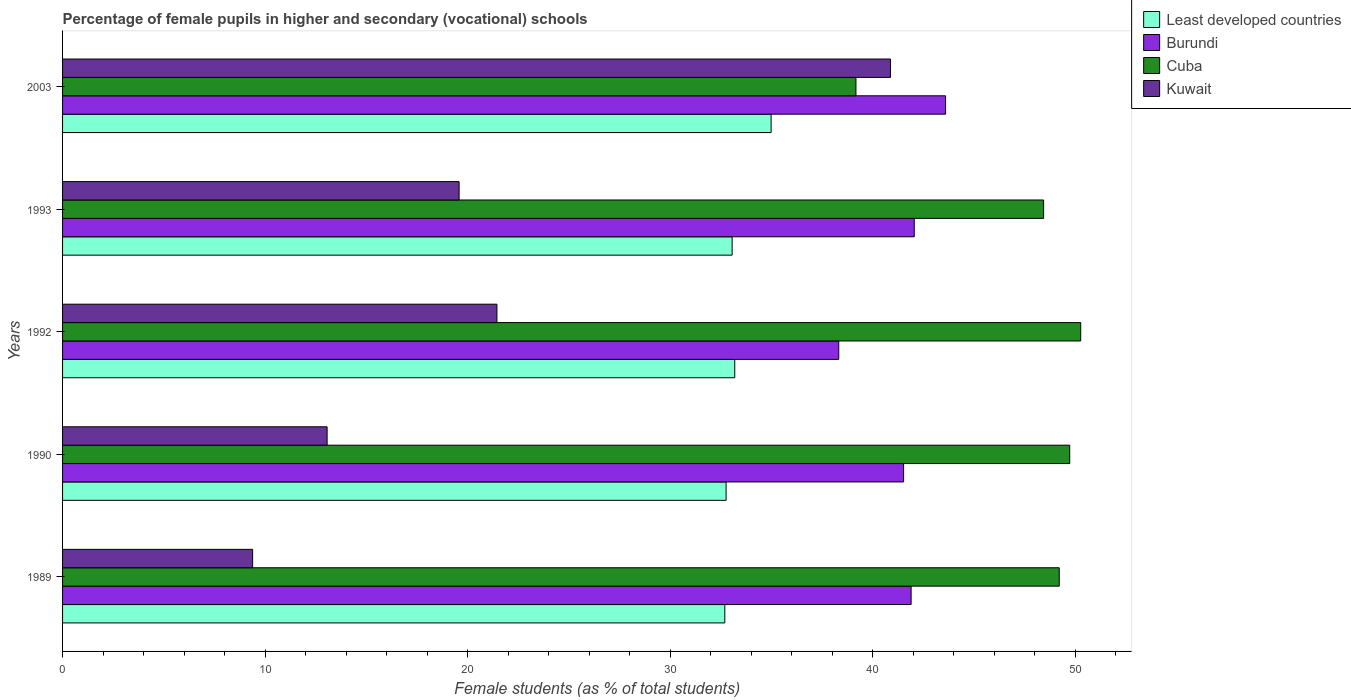How many different coloured bars are there?
Offer a terse response. 4. Are the number of bars on each tick of the Y-axis equal?
Ensure brevity in your answer.  Yes. What is the label of the 3rd group of bars from the top?
Your response must be concise. 1992. In how many cases, is the number of bars for a given year not equal to the number of legend labels?
Give a very brief answer. 0. What is the percentage of female pupils in higher and secondary schools in Least developed countries in 2003?
Your answer should be compact. 34.99. Across all years, what is the maximum percentage of female pupils in higher and secondary schools in Cuba?
Offer a terse response. 50.28. Across all years, what is the minimum percentage of female pupils in higher and secondary schools in Cuba?
Ensure brevity in your answer.  39.18. In which year was the percentage of female pupils in higher and secondary schools in Burundi maximum?
Your answer should be compact. 2003. In which year was the percentage of female pupils in higher and secondary schools in Kuwait minimum?
Ensure brevity in your answer.  1989. What is the total percentage of female pupils in higher and secondary schools in Burundi in the graph?
Provide a short and direct response. 207.43. What is the difference between the percentage of female pupils in higher and secondary schools in Kuwait in 1989 and that in 1990?
Offer a terse response. -3.68. What is the difference between the percentage of female pupils in higher and secondary schools in Burundi in 1990 and the percentage of female pupils in higher and secondary schools in Kuwait in 1989?
Provide a short and direct response. 32.15. What is the average percentage of female pupils in higher and secondary schools in Cuba per year?
Your answer should be compact. 47.37. In the year 1992, what is the difference between the percentage of female pupils in higher and secondary schools in Burundi and percentage of female pupils in higher and secondary schools in Cuba?
Your answer should be compact. -11.95. In how many years, is the percentage of female pupils in higher and secondary schools in Least developed countries greater than 40 %?
Offer a very short reply. 0. What is the ratio of the percentage of female pupils in higher and secondary schools in Kuwait in 1989 to that in 2003?
Your answer should be very brief. 0.23. Is the percentage of female pupils in higher and secondary schools in Least developed countries in 1990 less than that in 1993?
Keep it short and to the point. Yes. What is the difference between the highest and the second highest percentage of female pupils in higher and secondary schools in Burundi?
Give a very brief answer. 1.55. What is the difference between the highest and the lowest percentage of female pupils in higher and secondary schools in Cuba?
Offer a very short reply. 11.1. In how many years, is the percentage of female pupils in higher and secondary schools in Cuba greater than the average percentage of female pupils in higher and secondary schools in Cuba taken over all years?
Offer a very short reply. 4. What does the 1st bar from the top in 1993 represents?
Offer a very short reply. Kuwait. What does the 3rd bar from the bottom in 1989 represents?
Offer a terse response. Cuba. Is it the case that in every year, the sum of the percentage of female pupils in higher and secondary schools in Cuba and percentage of female pupils in higher and secondary schools in Burundi is greater than the percentage of female pupils in higher and secondary schools in Least developed countries?
Offer a terse response. Yes. How many bars are there?
Offer a very short reply. 20. How many years are there in the graph?
Ensure brevity in your answer.  5. Are the values on the major ticks of X-axis written in scientific E-notation?
Ensure brevity in your answer.  No. Does the graph contain grids?
Your answer should be very brief. No. What is the title of the graph?
Your response must be concise. Percentage of female pupils in higher and secondary (vocational) schools. What is the label or title of the X-axis?
Provide a short and direct response. Female students (as % of total students). What is the label or title of the Y-axis?
Provide a succinct answer. Years. What is the Female students (as % of total students) of Least developed countries in 1989?
Offer a very short reply. 32.7. What is the Female students (as % of total students) in Burundi in 1989?
Keep it short and to the point. 41.9. What is the Female students (as % of total students) of Cuba in 1989?
Give a very brief answer. 49.22. What is the Female students (as % of total students) in Kuwait in 1989?
Give a very brief answer. 9.39. What is the Female students (as % of total students) of Least developed countries in 1990?
Your response must be concise. 32.77. What is the Female students (as % of total students) of Burundi in 1990?
Keep it short and to the point. 41.53. What is the Female students (as % of total students) of Cuba in 1990?
Your response must be concise. 49.74. What is the Female students (as % of total students) in Kuwait in 1990?
Offer a terse response. 13.06. What is the Female students (as % of total students) in Least developed countries in 1992?
Your answer should be very brief. 33.2. What is the Female students (as % of total students) in Burundi in 1992?
Give a very brief answer. 38.33. What is the Female students (as % of total students) of Cuba in 1992?
Offer a terse response. 50.28. What is the Female students (as % of total students) in Kuwait in 1992?
Your response must be concise. 21.45. What is the Female students (as % of total students) in Least developed countries in 1993?
Ensure brevity in your answer.  33.07. What is the Female students (as % of total students) in Burundi in 1993?
Make the answer very short. 42.06. What is the Female students (as % of total students) of Cuba in 1993?
Keep it short and to the point. 48.45. What is the Female students (as % of total students) of Kuwait in 1993?
Give a very brief answer. 19.58. What is the Female students (as % of total students) of Least developed countries in 2003?
Keep it short and to the point. 34.99. What is the Female students (as % of total students) in Burundi in 2003?
Offer a terse response. 43.61. What is the Female students (as % of total students) in Cuba in 2003?
Keep it short and to the point. 39.18. What is the Female students (as % of total students) of Kuwait in 2003?
Provide a succinct answer. 40.88. Across all years, what is the maximum Female students (as % of total students) in Least developed countries?
Your response must be concise. 34.99. Across all years, what is the maximum Female students (as % of total students) of Burundi?
Make the answer very short. 43.61. Across all years, what is the maximum Female students (as % of total students) of Cuba?
Make the answer very short. 50.28. Across all years, what is the maximum Female students (as % of total students) in Kuwait?
Your answer should be compact. 40.88. Across all years, what is the minimum Female students (as % of total students) of Least developed countries?
Make the answer very short. 32.7. Across all years, what is the minimum Female students (as % of total students) in Burundi?
Give a very brief answer. 38.33. Across all years, what is the minimum Female students (as % of total students) of Cuba?
Offer a very short reply. 39.18. Across all years, what is the minimum Female students (as % of total students) of Kuwait?
Provide a succinct answer. 9.39. What is the total Female students (as % of total students) in Least developed countries in the graph?
Your answer should be very brief. 166.72. What is the total Female students (as % of total students) in Burundi in the graph?
Your answer should be compact. 207.43. What is the total Female students (as % of total students) in Cuba in the graph?
Make the answer very short. 236.87. What is the total Female students (as % of total students) in Kuwait in the graph?
Give a very brief answer. 104.37. What is the difference between the Female students (as % of total students) of Least developed countries in 1989 and that in 1990?
Keep it short and to the point. -0.06. What is the difference between the Female students (as % of total students) in Burundi in 1989 and that in 1990?
Make the answer very short. 0.37. What is the difference between the Female students (as % of total students) in Cuba in 1989 and that in 1990?
Give a very brief answer. -0.52. What is the difference between the Female students (as % of total students) of Kuwait in 1989 and that in 1990?
Your answer should be very brief. -3.68. What is the difference between the Female students (as % of total students) of Least developed countries in 1989 and that in 1992?
Provide a succinct answer. -0.49. What is the difference between the Female students (as % of total students) of Burundi in 1989 and that in 1992?
Your answer should be compact. 3.57. What is the difference between the Female students (as % of total students) of Cuba in 1989 and that in 1992?
Provide a short and direct response. -1.06. What is the difference between the Female students (as % of total students) in Kuwait in 1989 and that in 1992?
Your answer should be very brief. -12.07. What is the difference between the Female students (as % of total students) in Least developed countries in 1989 and that in 1993?
Your answer should be very brief. -0.36. What is the difference between the Female students (as % of total students) of Burundi in 1989 and that in 1993?
Offer a very short reply. -0.15. What is the difference between the Female students (as % of total students) of Cuba in 1989 and that in 1993?
Your answer should be compact. 0.77. What is the difference between the Female students (as % of total students) in Kuwait in 1989 and that in 1993?
Give a very brief answer. -10.2. What is the difference between the Female students (as % of total students) of Least developed countries in 1989 and that in 2003?
Your answer should be compact. -2.29. What is the difference between the Female students (as % of total students) in Burundi in 1989 and that in 2003?
Give a very brief answer. -1.7. What is the difference between the Female students (as % of total students) of Cuba in 1989 and that in 2003?
Your answer should be compact. 10.04. What is the difference between the Female students (as % of total students) of Kuwait in 1989 and that in 2003?
Your response must be concise. -31.5. What is the difference between the Female students (as % of total students) in Least developed countries in 1990 and that in 1992?
Keep it short and to the point. -0.43. What is the difference between the Female students (as % of total students) in Burundi in 1990 and that in 1992?
Give a very brief answer. 3.2. What is the difference between the Female students (as % of total students) of Cuba in 1990 and that in 1992?
Make the answer very short. -0.54. What is the difference between the Female students (as % of total students) of Kuwait in 1990 and that in 1992?
Your answer should be compact. -8.39. What is the difference between the Female students (as % of total students) in Least developed countries in 1990 and that in 1993?
Give a very brief answer. -0.3. What is the difference between the Female students (as % of total students) of Burundi in 1990 and that in 1993?
Provide a succinct answer. -0.53. What is the difference between the Female students (as % of total students) in Cuba in 1990 and that in 1993?
Your answer should be very brief. 1.29. What is the difference between the Female students (as % of total students) in Kuwait in 1990 and that in 1993?
Your answer should be very brief. -6.52. What is the difference between the Female students (as % of total students) of Least developed countries in 1990 and that in 2003?
Offer a terse response. -2.22. What is the difference between the Female students (as % of total students) of Burundi in 1990 and that in 2003?
Offer a terse response. -2.07. What is the difference between the Female students (as % of total students) of Cuba in 1990 and that in 2003?
Offer a terse response. 10.56. What is the difference between the Female students (as % of total students) of Kuwait in 1990 and that in 2003?
Your answer should be very brief. -27.82. What is the difference between the Female students (as % of total students) of Least developed countries in 1992 and that in 1993?
Provide a succinct answer. 0.13. What is the difference between the Female students (as % of total students) in Burundi in 1992 and that in 1993?
Your response must be concise. -3.73. What is the difference between the Female students (as % of total students) of Cuba in 1992 and that in 1993?
Your answer should be compact. 1.83. What is the difference between the Female students (as % of total students) of Kuwait in 1992 and that in 1993?
Give a very brief answer. 1.87. What is the difference between the Female students (as % of total students) of Least developed countries in 1992 and that in 2003?
Provide a short and direct response. -1.8. What is the difference between the Female students (as % of total students) of Burundi in 1992 and that in 2003?
Ensure brevity in your answer.  -5.28. What is the difference between the Female students (as % of total students) of Cuba in 1992 and that in 2003?
Keep it short and to the point. 11.1. What is the difference between the Female students (as % of total students) in Kuwait in 1992 and that in 2003?
Offer a very short reply. -19.43. What is the difference between the Female students (as % of total students) of Least developed countries in 1993 and that in 2003?
Offer a very short reply. -1.92. What is the difference between the Female students (as % of total students) of Burundi in 1993 and that in 2003?
Ensure brevity in your answer.  -1.55. What is the difference between the Female students (as % of total students) in Cuba in 1993 and that in 2003?
Your answer should be very brief. 9.27. What is the difference between the Female students (as % of total students) in Kuwait in 1993 and that in 2003?
Your response must be concise. -21.3. What is the difference between the Female students (as % of total students) in Least developed countries in 1989 and the Female students (as % of total students) in Burundi in 1990?
Your response must be concise. -8.83. What is the difference between the Female students (as % of total students) of Least developed countries in 1989 and the Female students (as % of total students) of Cuba in 1990?
Your answer should be compact. -17.03. What is the difference between the Female students (as % of total students) in Least developed countries in 1989 and the Female students (as % of total students) in Kuwait in 1990?
Ensure brevity in your answer.  19.64. What is the difference between the Female students (as % of total students) of Burundi in 1989 and the Female students (as % of total students) of Cuba in 1990?
Your answer should be very brief. -7.83. What is the difference between the Female students (as % of total students) of Burundi in 1989 and the Female students (as % of total students) of Kuwait in 1990?
Offer a very short reply. 28.84. What is the difference between the Female students (as % of total students) of Cuba in 1989 and the Female students (as % of total students) of Kuwait in 1990?
Make the answer very short. 36.16. What is the difference between the Female students (as % of total students) in Least developed countries in 1989 and the Female students (as % of total students) in Burundi in 1992?
Provide a succinct answer. -5.63. What is the difference between the Female students (as % of total students) in Least developed countries in 1989 and the Female students (as % of total students) in Cuba in 1992?
Make the answer very short. -17.58. What is the difference between the Female students (as % of total students) in Least developed countries in 1989 and the Female students (as % of total students) in Kuwait in 1992?
Offer a terse response. 11.25. What is the difference between the Female students (as % of total students) of Burundi in 1989 and the Female students (as % of total students) of Cuba in 1992?
Make the answer very short. -8.38. What is the difference between the Female students (as % of total students) of Burundi in 1989 and the Female students (as % of total students) of Kuwait in 1992?
Your response must be concise. 20.45. What is the difference between the Female students (as % of total students) in Cuba in 1989 and the Female students (as % of total students) in Kuwait in 1992?
Give a very brief answer. 27.77. What is the difference between the Female students (as % of total students) of Least developed countries in 1989 and the Female students (as % of total students) of Burundi in 1993?
Offer a very short reply. -9.36. What is the difference between the Female students (as % of total students) in Least developed countries in 1989 and the Female students (as % of total students) in Cuba in 1993?
Make the answer very short. -15.74. What is the difference between the Female students (as % of total students) in Least developed countries in 1989 and the Female students (as % of total students) in Kuwait in 1993?
Ensure brevity in your answer.  13.12. What is the difference between the Female students (as % of total students) in Burundi in 1989 and the Female students (as % of total students) in Cuba in 1993?
Your answer should be very brief. -6.54. What is the difference between the Female students (as % of total students) of Burundi in 1989 and the Female students (as % of total students) of Kuwait in 1993?
Make the answer very short. 22.32. What is the difference between the Female students (as % of total students) in Cuba in 1989 and the Female students (as % of total students) in Kuwait in 1993?
Offer a terse response. 29.64. What is the difference between the Female students (as % of total students) of Least developed countries in 1989 and the Female students (as % of total students) of Burundi in 2003?
Make the answer very short. -10.9. What is the difference between the Female students (as % of total students) of Least developed countries in 1989 and the Female students (as % of total students) of Cuba in 2003?
Offer a very short reply. -6.48. What is the difference between the Female students (as % of total students) of Least developed countries in 1989 and the Female students (as % of total students) of Kuwait in 2003?
Offer a very short reply. -8.18. What is the difference between the Female students (as % of total students) of Burundi in 1989 and the Female students (as % of total students) of Cuba in 2003?
Give a very brief answer. 2.72. What is the difference between the Female students (as % of total students) of Burundi in 1989 and the Female students (as % of total students) of Kuwait in 2003?
Give a very brief answer. 1.02. What is the difference between the Female students (as % of total students) in Cuba in 1989 and the Female students (as % of total students) in Kuwait in 2003?
Offer a terse response. 8.34. What is the difference between the Female students (as % of total students) of Least developed countries in 1990 and the Female students (as % of total students) of Burundi in 1992?
Ensure brevity in your answer.  -5.56. What is the difference between the Female students (as % of total students) of Least developed countries in 1990 and the Female students (as % of total students) of Cuba in 1992?
Keep it short and to the point. -17.51. What is the difference between the Female students (as % of total students) of Least developed countries in 1990 and the Female students (as % of total students) of Kuwait in 1992?
Your answer should be compact. 11.32. What is the difference between the Female students (as % of total students) of Burundi in 1990 and the Female students (as % of total students) of Cuba in 1992?
Ensure brevity in your answer.  -8.75. What is the difference between the Female students (as % of total students) of Burundi in 1990 and the Female students (as % of total students) of Kuwait in 1992?
Your answer should be very brief. 20.08. What is the difference between the Female students (as % of total students) of Cuba in 1990 and the Female students (as % of total students) of Kuwait in 1992?
Provide a short and direct response. 28.29. What is the difference between the Female students (as % of total students) in Least developed countries in 1990 and the Female students (as % of total students) in Burundi in 1993?
Give a very brief answer. -9.29. What is the difference between the Female students (as % of total students) of Least developed countries in 1990 and the Female students (as % of total students) of Cuba in 1993?
Your answer should be compact. -15.68. What is the difference between the Female students (as % of total students) in Least developed countries in 1990 and the Female students (as % of total students) in Kuwait in 1993?
Your answer should be very brief. 13.18. What is the difference between the Female students (as % of total students) of Burundi in 1990 and the Female students (as % of total students) of Cuba in 1993?
Make the answer very short. -6.91. What is the difference between the Female students (as % of total students) in Burundi in 1990 and the Female students (as % of total students) in Kuwait in 1993?
Provide a short and direct response. 21.95. What is the difference between the Female students (as % of total students) in Cuba in 1990 and the Female students (as % of total students) in Kuwait in 1993?
Give a very brief answer. 30.15. What is the difference between the Female students (as % of total students) of Least developed countries in 1990 and the Female students (as % of total students) of Burundi in 2003?
Provide a short and direct response. -10.84. What is the difference between the Female students (as % of total students) in Least developed countries in 1990 and the Female students (as % of total students) in Cuba in 2003?
Provide a succinct answer. -6.41. What is the difference between the Female students (as % of total students) of Least developed countries in 1990 and the Female students (as % of total students) of Kuwait in 2003?
Provide a succinct answer. -8.12. What is the difference between the Female students (as % of total students) in Burundi in 1990 and the Female students (as % of total students) in Cuba in 2003?
Offer a very short reply. 2.35. What is the difference between the Female students (as % of total students) in Burundi in 1990 and the Female students (as % of total students) in Kuwait in 2003?
Provide a succinct answer. 0.65. What is the difference between the Female students (as % of total students) in Cuba in 1990 and the Female students (as % of total students) in Kuwait in 2003?
Keep it short and to the point. 8.85. What is the difference between the Female students (as % of total students) in Least developed countries in 1992 and the Female students (as % of total students) in Burundi in 1993?
Your answer should be compact. -8.86. What is the difference between the Female students (as % of total students) of Least developed countries in 1992 and the Female students (as % of total students) of Cuba in 1993?
Your answer should be very brief. -15.25. What is the difference between the Female students (as % of total students) of Least developed countries in 1992 and the Female students (as % of total students) of Kuwait in 1993?
Keep it short and to the point. 13.61. What is the difference between the Female students (as % of total students) of Burundi in 1992 and the Female students (as % of total students) of Cuba in 1993?
Your response must be concise. -10.12. What is the difference between the Female students (as % of total students) in Burundi in 1992 and the Female students (as % of total students) in Kuwait in 1993?
Your answer should be very brief. 18.75. What is the difference between the Female students (as % of total students) in Cuba in 1992 and the Female students (as % of total students) in Kuwait in 1993?
Your answer should be compact. 30.7. What is the difference between the Female students (as % of total students) of Least developed countries in 1992 and the Female students (as % of total students) of Burundi in 2003?
Your response must be concise. -10.41. What is the difference between the Female students (as % of total students) in Least developed countries in 1992 and the Female students (as % of total students) in Cuba in 2003?
Offer a very short reply. -5.99. What is the difference between the Female students (as % of total students) in Least developed countries in 1992 and the Female students (as % of total students) in Kuwait in 2003?
Your response must be concise. -7.69. What is the difference between the Female students (as % of total students) in Burundi in 1992 and the Female students (as % of total students) in Cuba in 2003?
Keep it short and to the point. -0.85. What is the difference between the Female students (as % of total students) in Burundi in 1992 and the Female students (as % of total students) in Kuwait in 2003?
Give a very brief answer. -2.55. What is the difference between the Female students (as % of total students) of Cuba in 1992 and the Female students (as % of total students) of Kuwait in 2003?
Ensure brevity in your answer.  9.4. What is the difference between the Female students (as % of total students) of Least developed countries in 1993 and the Female students (as % of total students) of Burundi in 2003?
Your answer should be very brief. -10.54. What is the difference between the Female students (as % of total students) in Least developed countries in 1993 and the Female students (as % of total students) in Cuba in 2003?
Your answer should be very brief. -6.11. What is the difference between the Female students (as % of total students) in Least developed countries in 1993 and the Female students (as % of total students) in Kuwait in 2003?
Provide a succinct answer. -7.82. What is the difference between the Female students (as % of total students) in Burundi in 1993 and the Female students (as % of total students) in Cuba in 2003?
Your response must be concise. 2.88. What is the difference between the Female students (as % of total students) of Burundi in 1993 and the Female students (as % of total students) of Kuwait in 2003?
Keep it short and to the point. 1.18. What is the difference between the Female students (as % of total students) in Cuba in 1993 and the Female students (as % of total students) in Kuwait in 2003?
Provide a short and direct response. 7.56. What is the average Female students (as % of total students) of Least developed countries per year?
Offer a terse response. 33.34. What is the average Female students (as % of total students) in Burundi per year?
Ensure brevity in your answer.  41.49. What is the average Female students (as % of total students) in Cuba per year?
Your answer should be very brief. 47.37. What is the average Female students (as % of total students) in Kuwait per year?
Make the answer very short. 20.87. In the year 1989, what is the difference between the Female students (as % of total students) of Least developed countries and Female students (as % of total students) of Burundi?
Provide a succinct answer. -9.2. In the year 1989, what is the difference between the Female students (as % of total students) in Least developed countries and Female students (as % of total students) in Cuba?
Ensure brevity in your answer.  -16.52. In the year 1989, what is the difference between the Female students (as % of total students) in Least developed countries and Female students (as % of total students) in Kuwait?
Ensure brevity in your answer.  23.32. In the year 1989, what is the difference between the Female students (as % of total students) of Burundi and Female students (as % of total students) of Cuba?
Make the answer very short. -7.32. In the year 1989, what is the difference between the Female students (as % of total students) of Burundi and Female students (as % of total students) of Kuwait?
Your answer should be compact. 32.52. In the year 1989, what is the difference between the Female students (as % of total students) of Cuba and Female students (as % of total students) of Kuwait?
Make the answer very short. 39.83. In the year 1990, what is the difference between the Female students (as % of total students) in Least developed countries and Female students (as % of total students) in Burundi?
Provide a short and direct response. -8.77. In the year 1990, what is the difference between the Female students (as % of total students) of Least developed countries and Female students (as % of total students) of Cuba?
Your answer should be compact. -16.97. In the year 1990, what is the difference between the Female students (as % of total students) in Least developed countries and Female students (as % of total students) in Kuwait?
Your response must be concise. 19.7. In the year 1990, what is the difference between the Female students (as % of total students) of Burundi and Female students (as % of total students) of Cuba?
Offer a very short reply. -8.2. In the year 1990, what is the difference between the Female students (as % of total students) of Burundi and Female students (as % of total students) of Kuwait?
Offer a very short reply. 28.47. In the year 1990, what is the difference between the Female students (as % of total students) in Cuba and Female students (as % of total students) in Kuwait?
Your response must be concise. 36.67. In the year 1992, what is the difference between the Female students (as % of total students) in Least developed countries and Female students (as % of total students) in Burundi?
Your answer should be very brief. -5.14. In the year 1992, what is the difference between the Female students (as % of total students) of Least developed countries and Female students (as % of total students) of Cuba?
Keep it short and to the point. -17.09. In the year 1992, what is the difference between the Female students (as % of total students) of Least developed countries and Female students (as % of total students) of Kuwait?
Provide a short and direct response. 11.74. In the year 1992, what is the difference between the Female students (as % of total students) of Burundi and Female students (as % of total students) of Cuba?
Your answer should be very brief. -11.95. In the year 1992, what is the difference between the Female students (as % of total students) of Burundi and Female students (as % of total students) of Kuwait?
Make the answer very short. 16.88. In the year 1992, what is the difference between the Female students (as % of total students) of Cuba and Female students (as % of total students) of Kuwait?
Provide a short and direct response. 28.83. In the year 1993, what is the difference between the Female students (as % of total students) of Least developed countries and Female students (as % of total students) of Burundi?
Offer a very short reply. -8.99. In the year 1993, what is the difference between the Female students (as % of total students) of Least developed countries and Female students (as % of total students) of Cuba?
Give a very brief answer. -15.38. In the year 1993, what is the difference between the Female students (as % of total students) in Least developed countries and Female students (as % of total students) in Kuwait?
Offer a terse response. 13.48. In the year 1993, what is the difference between the Female students (as % of total students) of Burundi and Female students (as % of total students) of Cuba?
Keep it short and to the point. -6.39. In the year 1993, what is the difference between the Female students (as % of total students) of Burundi and Female students (as % of total students) of Kuwait?
Make the answer very short. 22.48. In the year 1993, what is the difference between the Female students (as % of total students) of Cuba and Female students (as % of total students) of Kuwait?
Your answer should be compact. 28.86. In the year 2003, what is the difference between the Female students (as % of total students) in Least developed countries and Female students (as % of total students) in Burundi?
Ensure brevity in your answer.  -8.62. In the year 2003, what is the difference between the Female students (as % of total students) in Least developed countries and Female students (as % of total students) in Cuba?
Your response must be concise. -4.19. In the year 2003, what is the difference between the Female students (as % of total students) in Least developed countries and Female students (as % of total students) in Kuwait?
Offer a terse response. -5.89. In the year 2003, what is the difference between the Female students (as % of total students) in Burundi and Female students (as % of total students) in Cuba?
Make the answer very short. 4.43. In the year 2003, what is the difference between the Female students (as % of total students) of Burundi and Female students (as % of total students) of Kuwait?
Ensure brevity in your answer.  2.72. In the year 2003, what is the difference between the Female students (as % of total students) of Cuba and Female students (as % of total students) of Kuwait?
Make the answer very short. -1.7. What is the ratio of the Female students (as % of total students) in Burundi in 1989 to that in 1990?
Give a very brief answer. 1.01. What is the ratio of the Female students (as % of total students) of Cuba in 1989 to that in 1990?
Provide a short and direct response. 0.99. What is the ratio of the Female students (as % of total students) of Kuwait in 1989 to that in 1990?
Your answer should be very brief. 0.72. What is the ratio of the Female students (as % of total students) of Least developed countries in 1989 to that in 1992?
Offer a terse response. 0.99. What is the ratio of the Female students (as % of total students) in Burundi in 1989 to that in 1992?
Make the answer very short. 1.09. What is the ratio of the Female students (as % of total students) in Cuba in 1989 to that in 1992?
Ensure brevity in your answer.  0.98. What is the ratio of the Female students (as % of total students) in Kuwait in 1989 to that in 1992?
Provide a short and direct response. 0.44. What is the ratio of the Female students (as % of total students) in Burundi in 1989 to that in 1993?
Make the answer very short. 1. What is the ratio of the Female students (as % of total students) in Cuba in 1989 to that in 1993?
Offer a very short reply. 1.02. What is the ratio of the Female students (as % of total students) of Kuwait in 1989 to that in 1993?
Ensure brevity in your answer.  0.48. What is the ratio of the Female students (as % of total students) in Least developed countries in 1989 to that in 2003?
Your response must be concise. 0.93. What is the ratio of the Female students (as % of total students) of Burundi in 1989 to that in 2003?
Offer a very short reply. 0.96. What is the ratio of the Female students (as % of total students) of Cuba in 1989 to that in 2003?
Ensure brevity in your answer.  1.26. What is the ratio of the Female students (as % of total students) in Kuwait in 1989 to that in 2003?
Keep it short and to the point. 0.23. What is the ratio of the Female students (as % of total students) in Least developed countries in 1990 to that in 1992?
Give a very brief answer. 0.99. What is the ratio of the Female students (as % of total students) in Burundi in 1990 to that in 1992?
Keep it short and to the point. 1.08. What is the ratio of the Female students (as % of total students) of Cuba in 1990 to that in 1992?
Keep it short and to the point. 0.99. What is the ratio of the Female students (as % of total students) in Kuwait in 1990 to that in 1992?
Your response must be concise. 0.61. What is the ratio of the Female students (as % of total students) of Least developed countries in 1990 to that in 1993?
Offer a very short reply. 0.99. What is the ratio of the Female students (as % of total students) in Burundi in 1990 to that in 1993?
Provide a succinct answer. 0.99. What is the ratio of the Female students (as % of total students) of Cuba in 1990 to that in 1993?
Offer a terse response. 1.03. What is the ratio of the Female students (as % of total students) in Kuwait in 1990 to that in 1993?
Offer a terse response. 0.67. What is the ratio of the Female students (as % of total students) of Least developed countries in 1990 to that in 2003?
Offer a very short reply. 0.94. What is the ratio of the Female students (as % of total students) in Burundi in 1990 to that in 2003?
Provide a succinct answer. 0.95. What is the ratio of the Female students (as % of total students) of Cuba in 1990 to that in 2003?
Your answer should be compact. 1.27. What is the ratio of the Female students (as % of total students) in Kuwait in 1990 to that in 2003?
Your answer should be compact. 0.32. What is the ratio of the Female students (as % of total students) in Least developed countries in 1992 to that in 1993?
Your answer should be compact. 1. What is the ratio of the Female students (as % of total students) of Burundi in 1992 to that in 1993?
Your answer should be compact. 0.91. What is the ratio of the Female students (as % of total students) in Cuba in 1992 to that in 1993?
Ensure brevity in your answer.  1.04. What is the ratio of the Female students (as % of total students) of Kuwait in 1992 to that in 1993?
Your answer should be compact. 1.1. What is the ratio of the Female students (as % of total students) of Least developed countries in 1992 to that in 2003?
Your response must be concise. 0.95. What is the ratio of the Female students (as % of total students) in Burundi in 1992 to that in 2003?
Your answer should be very brief. 0.88. What is the ratio of the Female students (as % of total students) in Cuba in 1992 to that in 2003?
Offer a very short reply. 1.28. What is the ratio of the Female students (as % of total students) of Kuwait in 1992 to that in 2003?
Provide a short and direct response. 0.52. What is the ratio of the Female students (as % of total students) in Least developed countries in 1993 to that in 2003?
Provide a short and direct response. 0.94. What is the ratio of the Female students (as % of total students) in Burundi in 1993 to that in 2003?
Your answer should be compact. 0.96. What is the ratio of the Female students (as % of total students) in Cuba in 1993 to that in 2003?
Provide a short and direct response. 1.24. What is the ratio of the Female students (as % of total students) of Kuwait in 1993 to that in 2003?
Provide a short and direct response. 0.48. What is the difference between the highest and the second highest Female students (as % of total students) of Least developed countries?
Keep it short and to the point. 1.8. What is the difference between the highest and the second highest Female students (as % of total students) in Burundi?
Provide a short and direct response. 1.55. What is the difference between the highest and the second highest Female students (as % of total students) of Cuba?
Your answer should be compact. 0.54. What is the difference between the highest and the second highest Female students (as % of total students) in Kuwait?
Give a very brief answer. 19.43. What is the difference between the highest and the lowest Female students (as % of total students) of Least developed countries?
Your answer should be compact. 2.29. What is the difference between the highest and the lowest Female students (as % of total students) in Burundi?
Keep it short and to the point. 5.28. What is the difference between the highest and the lowest Female students (as % of total students) of Cuba?
Your answer should be compact. 11.1. What is the difference between the highest and the lowest Female students (as % of total students) of Kuwait?
Make the answer very short. 31.5. 